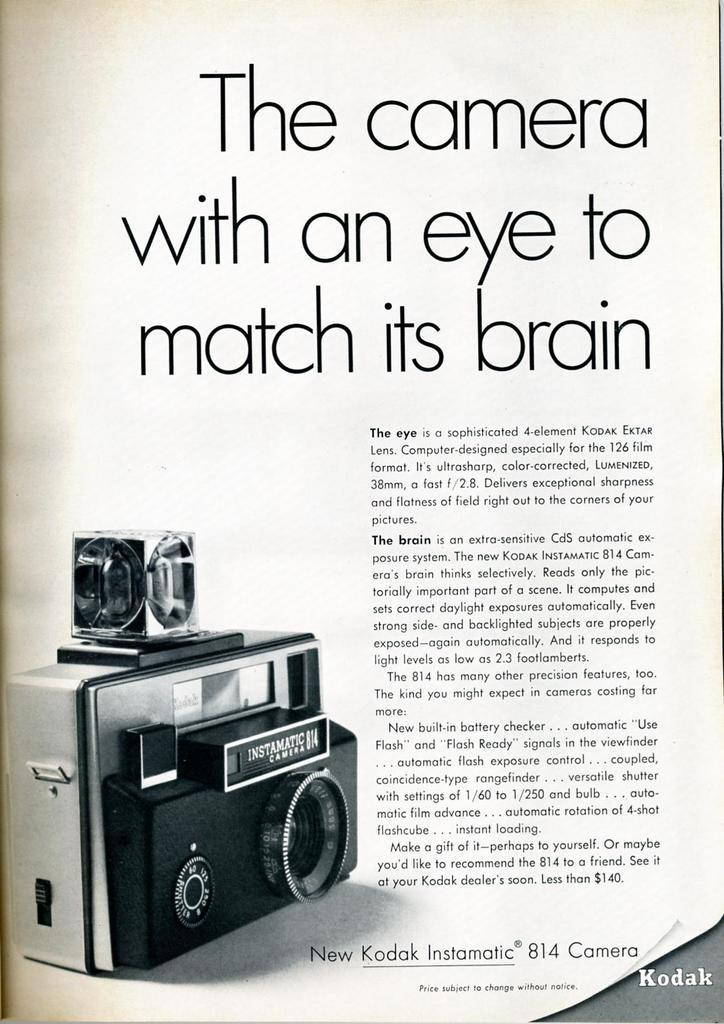What is featured in the image in the poster? The poster contains an image of a camera. What else can be seen on the poster besides the camera image? There is text on the poster. How many giants are depicted on the poster? There are no giants depicted on the poster; it features an image of a camera and text. What type of flock is visible in the image? There is no flock present in the image; it only contains a poster with a camera image and text. 